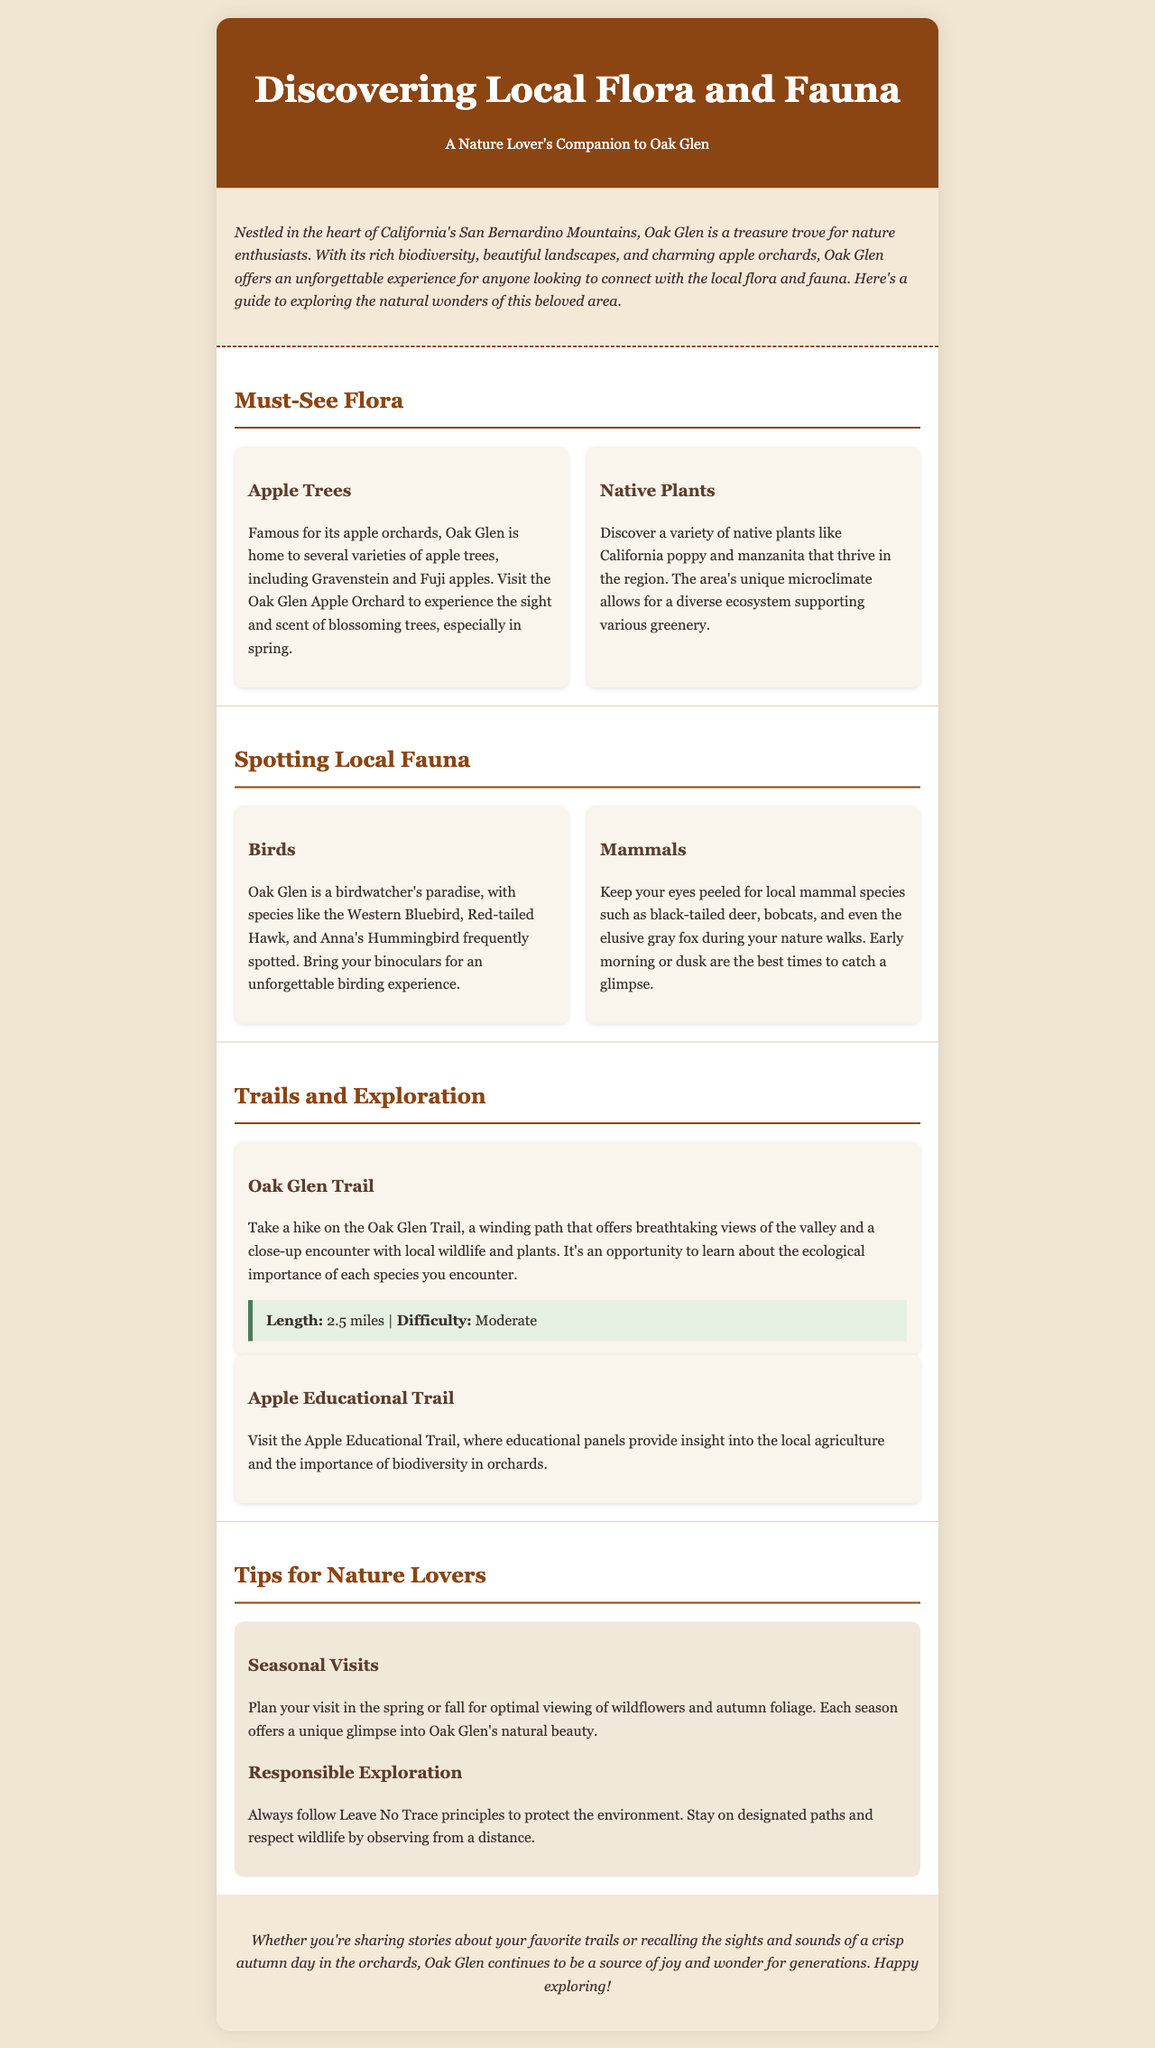what type of trees is Oak Glen famous for? The document mentions that Oak Glen is famous for its apple orchards, including various types of apple trees.
Answer: apple trees what are two native plants found in Oak Glen? The section on must-see flora lists California poppy and manzanita as native plants in the region.
Answer: California poppy, manzanita which hawk species can be spotted in Oak Glen? The document specifically highlights the presence of the Red-tailed Hawk among the bird species found here.
Answer: Red-tailed Hawk how long is the Oak Glen Trail? The document states the length of the Oak Glen Trail in the section about trails and exploration.
Answer: 2.5 miles what should you follow to protect the environment while exploring? The tips section advises following Leave No Trace principles to ensure environmental protection.
Answer: Leave No Trace principles which season is suggested for optimal viewing of wildflowers? The tips section mentions planning visits in spring or fall for the best views of wildflowers.
Answer: spring how many types of wildlife are mentioned in the section about spotting local fauna? The document refers to various types of fauna, specifically naming birds and mammals as the two categories mentioned.
Answer: two what is the difficulty level of the Oak Glen Trail? The document outlines the difficulty level of the Oak Glen Trail in the trail information.
Answer: Moderate what is provided along the Apple Educational Trail? The document states that educational panels are present along the Apple Educational Trail to offer insights.
Answer: educational panels 